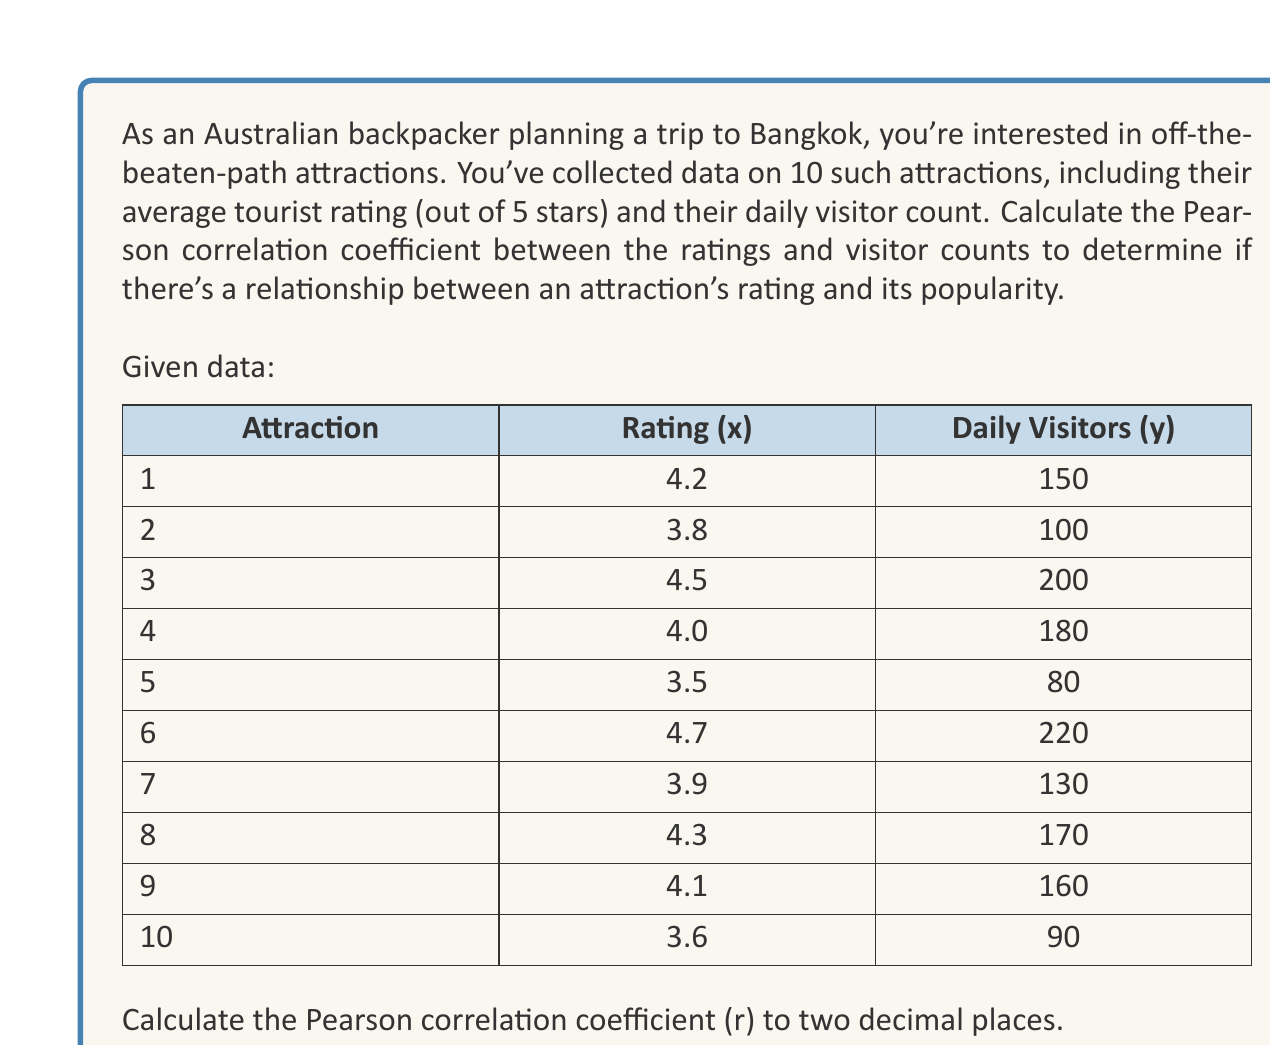Can you answer this question? To calculate the Pearson correlation coefficient (r), we'll use the formula:

$$ r = \frac{\sum_{i=1}^{n} (x_i - \bar{x})(y_i - \bar{y})}{\sqrt{\sum_{i=1}^{n} (x_i - \bar{x})^2 \sum_{i=1}^{n} (y_i - \bar{y})^2}} $$

Where:
$x_i$ = individual rating values
$y_i$ = individual daily visitor counts
$\bar{x}$ = mean of ratings
$\bar{y}$ = mean of daily visitor counts
$n$ = number of attractions (10)

Step 1: Calculate means
$\bar{x} = \frac{4.2 + 3.8 + 4.5 + 4.0 + 3.5 + 4.7 + 3.9 + 4.3 + 4.1 + 3.6}{10} = 4.06$
$\bar{y} = \frac{150 + 100 + 200 + 180 + 80 + 220 + 130 + 170 + 160 + 90}{10} = 148$

Step 2: Calculate $(x_i - \bar{x})$, $(y_i - \bar{y})$, $(x_i - \bar{x})^2$, $(y_i - \bar{y})^2$, and $(x_i - \bar{x})(y_i - \bar{y})$ for each attraction.

Step 3: Sum the calculated values:
$\sum (x_i - \bar{x})(y_i - \bar{y}) = 1645.6$
$\sum (x_i - \bar{x})^2 = 1.364$
$\sum (y_i - \bar{y})^2 = 26320$

Step 4: Apply the formula:

$$ r = \frac{1645.6}{\sqrt{1.364 \times 26320}} = \frac{1645.6}{189.44} = 0.8686 $$

Step 5: Round to two decimal places: 0.87
Answer: The Pearson correlation coefficient (r) between the ratings and daily visitor counts for the off-the-beaten-path attractions in Bangkok is 0.87. 